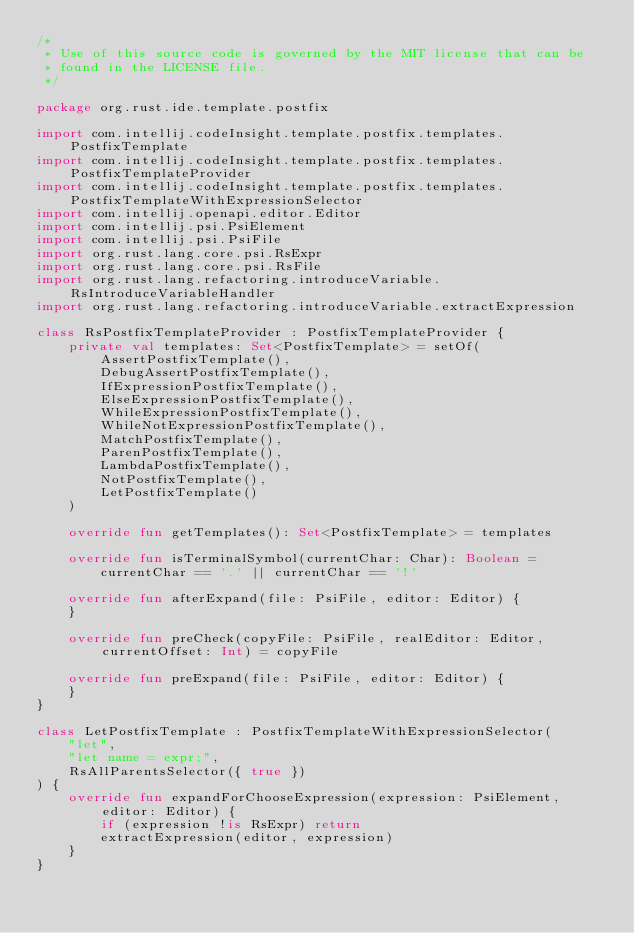<code> <loc_0><loc_0><loc_500><loc_500><_Kotlin_>/*
 * Use of this source code is governed by the MIT license that can be
 * found in the LICENSE file.
 */

package org.rust.ide.template.postfix

import com.intellij.codeInsight.template.postfix.templates.PostfixTemplate
import com.intellij.codeInsight.template.postfix.templates.PostfixTemplateProvider
import com.intellij.codeInsight.template.postfix.templates.PostfixTemplateWithExpressionSelector
import com.intellij.openapi.editor.Editor
import com.intellij.psi.PsiElement
import com.intellij.psi.PsiFile
import org.rust.lang.core.psi.RsExpr
import org.rust.lang.core.psi.RsFile
import org.rust.lang.refactoring.introduceVariable.RsIntroduceVariableHandler
import org.rust.lang.refactoring.introduceVariable.extractExpression

class RsPostfixTemplateProvider : PostfixTemplateProvider {
    private val templates: Set<PostfixTemplate> = setOf(
        AssertPostfixTemplate(),
        DebugAssertPostfixTemplate(),
        IfExpressionPostfixTemplate(),
        ElseExpressionPostfixTemplate(),
        WhileExpressionPostfixTemplate(),
        WhileNotExpressionPostfixTemplate(),
        MatchPostfixTemplate(),
        ParenPostfixTemplate(),
        LambdaPostfixTemplate(),
        NotPostfixTemplate(),
        LetPostfixTemplate()
    )

    override fun getTemplates(): Set<PostfixTemplate> = templates

    override fun isTerminalSymbol(currentChar: Char): Boolean =
        currentChar == '.' || currentChar == '!'

    override fun afterExpand(file: PsiFile, editor: Editor) {
    }

    override fun preCheck(copyFile: PsiFile, realEditor: Editor, currentOffset: Int) = copyFile

    override fun preExpand(file: PsiFile, editor: Editor) {
    }
}

class LetPostfixTemplate : PostfixTemplateWithExpressionSelector(
    "let",
    "let name = expr;",
    RsAllParentsSelector({ true })
) {
    override fun expandForChooseExpression(expression: PsiElement, editor: Editor) {
        if (expression !is RsExpr) return
        extractExpression(editor, expression)
    }
}
</code> 